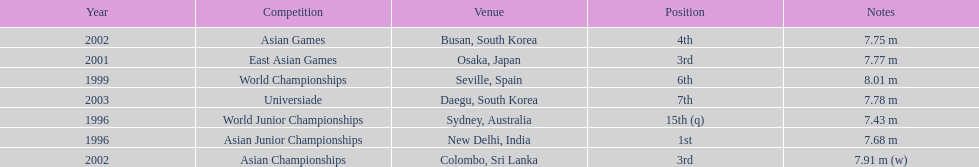How many times did his jump surpass 7.70 m? 5. 